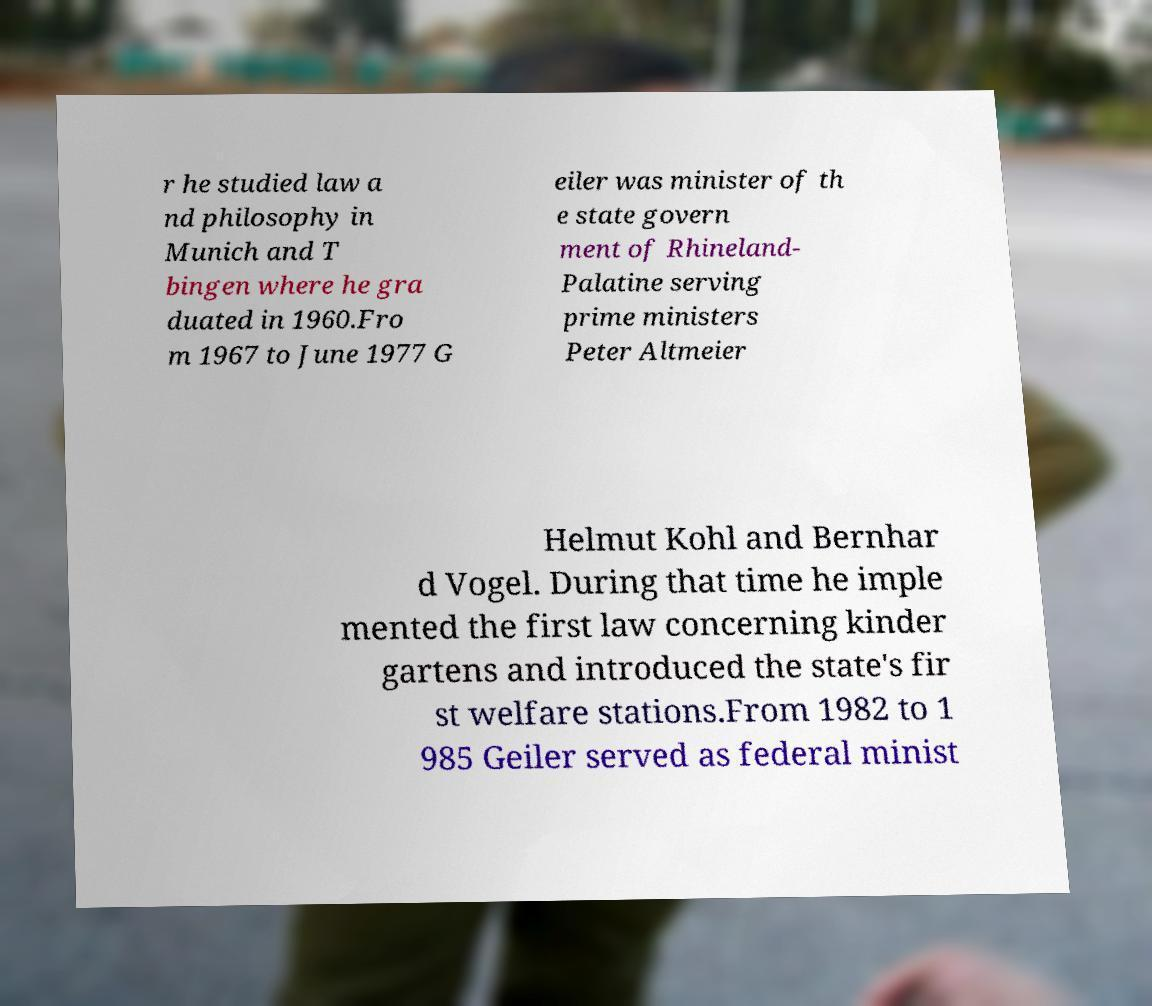Please identify and transcribe the text found in this image. r he studied law a nd philosophy in Munich and T bingen where he gra duated in 1960.Fro m 1967 to June 1977 G eiler was minister of th e state govern ment of Rhineland- Palatine serving prime ministers Peter Altmeier Helmut Kohl and Bernhar d Vogel. During that time he imple mented the first law concerning kinder gartens and introduced the state's fir st welfare stations.From 1982 to 1 985 Geiler served as federal minist 